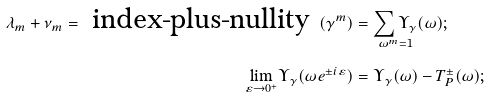Convert formula to latex. <formula><loc_0><loc_0><loc_500><loc_500>\lambda _ { m } + \nu _ { m } = \text { index-plus-nullity } ( \gamma ^ { m } ) & = \underset { \omega ^ { m } = 1 } { \sum \Upsilon _ { \gamma } } ( \omega ) ; \\ \underset { \varepsilon \rightarrow 0 ^ { + } } { \lim } \Upsilon _ { \gamma } ( \omega e ^ { \pm i \varepsilon } ) & = \Upsilon _ { \gamma } ( \omega ) - T _ { P } ^ { \pm } ( \omega ) ;</formula> 